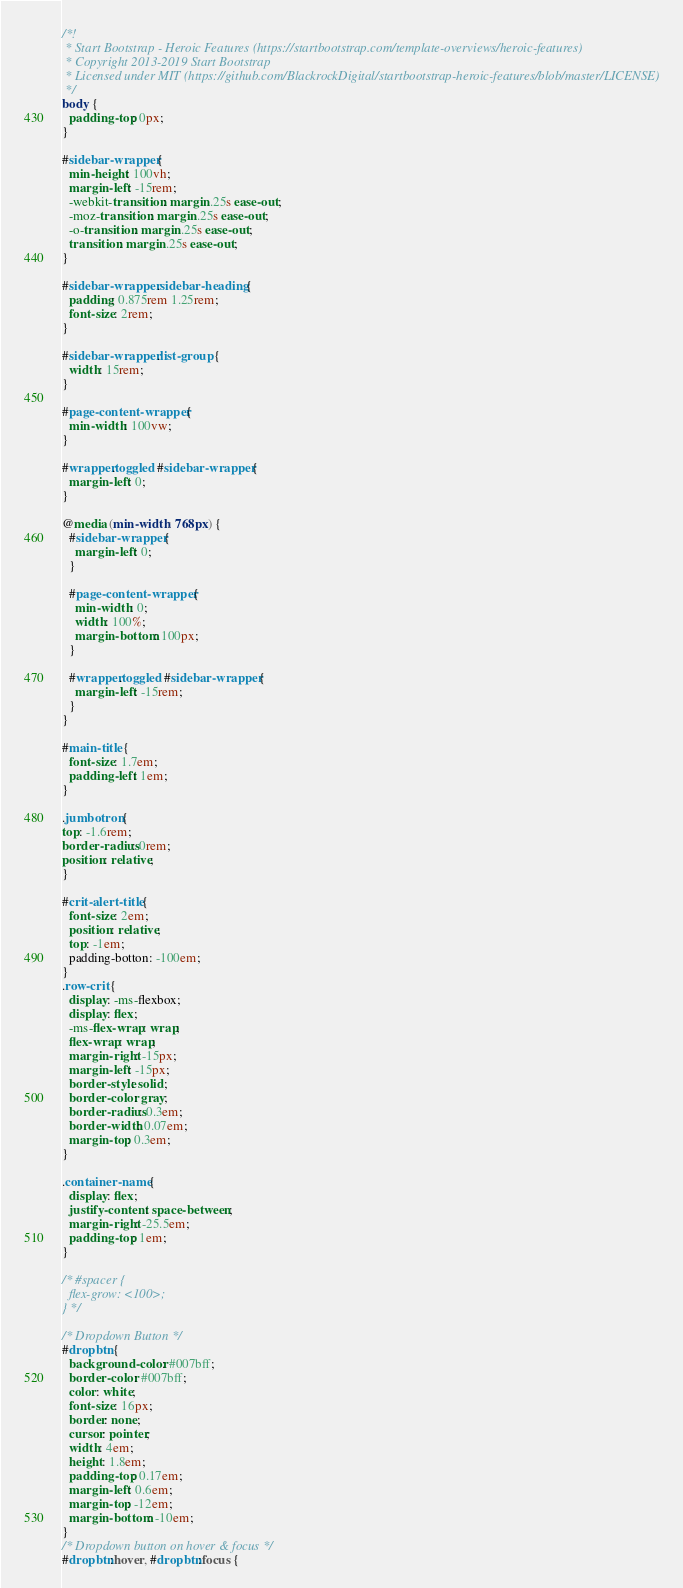Convert code to text. <code><loc_0><loc_0><loc_500><loc_500><_CSS_>/*!
 * Start Bootstrap - Heroic Features (https://startbootstrap.com/template-overviews/heroic-features)
 * Copyright 2013-2019 Start Bootstrap
 * Licensed under MIT (https://github.com/BlackrockDigital/startbootstrap-heroic-features/blob/master/LICENSE)
 */
body {
  padding-top: 0px;
}

#sidebar-wrapper {
  min-height: 100vh;
  margin-left: -15rem;
  -webkit-transition: margin .25s ease-out;
  -moz-transition: margin .25s ease-out;
  -o-transition: margin .25s ease-out;
  transition: margin .25s ease-out;
}

#sidebar-wrapper .sidebar-heading {
  padding: 0.875rem 1.25rem;
  font-size: 2rem;
}

#sidebar-wrapper .list-group {
  width: 15rem;
}

#page-content-wrapper {
  min-width: 100vw;
}

#wrapper.toggled #sidebar-wrapper {
  margin-left: 0;
}

@media (min-width: 768px) {
  #sidebar-wrapper {
    margin-left: 0;
  }

  #page-content-wrapper {
    min-width: 0;
    width: 100%;
    margin-bottom: 100px;
  }

  #wrapper.toggled #sidebar-wrapper {
    margin-left: -15rem;
  }
}

#main-title {
  font-size: 1.7em;
  padding-left: 1em;
}

.jumbotron {
top: -1.6rem;
border-radius: 0rem;
position: relative;
}

#crit-alert-title {
  font-size: 2em;
  position: relative;
  top: -1em;
  padding-botton: -100em;
}
.row-crit {
  display: -ms-flexbox;
  display: flex;
  -ms-flex-wrap: wrap;
  flex-wrap: wrap;
  margin-right: -15px;
  margin-left: -15px;
  border-style: solid;
  border-color: gray;
  border-radius: 0.3em;
  border-width: 0.07em;
  margin-top: 0.3em;
}

.container-name {
  display: flex;
  justify-content: space-between;
  margin-right: -25.5em;
  padding-top: 1em;
}

/* #spacer {
  flex-grow: <100>;
} */

/* Dropdown Button */
#dropbtn {
  background-color: #007bff;
  border-color: #007bff;
  color: white;
  font-size: 16px;
  border: none;
  cursor: pointer;
  width: 4em;
  height: 1.8em;
  padding-top: 0.17em;
  margin-left: 0.6em;
  margin-top: -12em;
  margin-bottom: -10em;
}
/* Dropdown button on hover & focus */
#dropbtn:hover, #dropbtn:focus {</code> 